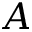Convert formula to latex. <formula><loc_0><loc_0><loc_500><loc_500>A</formula> 